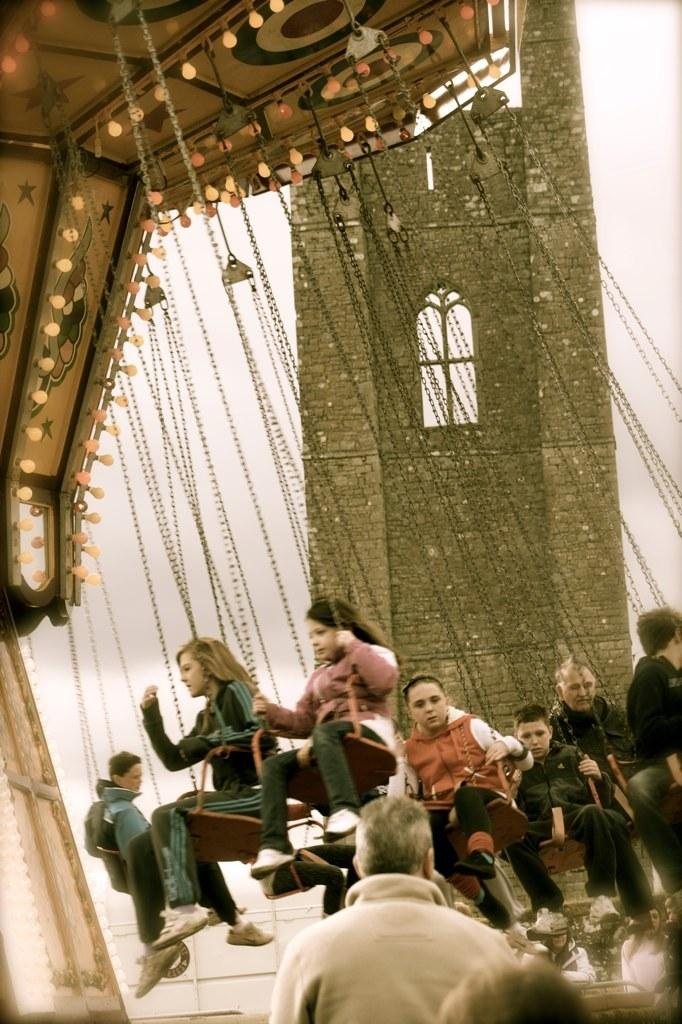How many people are in the image? There is a group of people in the image, but the exact number cannot be determined from the provided facts. What are the people doing in the image? Some people are sitting on objects in the image. How are the objects connected to the people? The objects are attached with chains. What can be seen in the background of the image? There is sky and a building visible in the background of the image. What type of yam is being used as a learning tool in the image? There is no yam or learning tool present in the image. What is on the list that the people are discussing in the image? There is no list or discussion about a list in the image. 